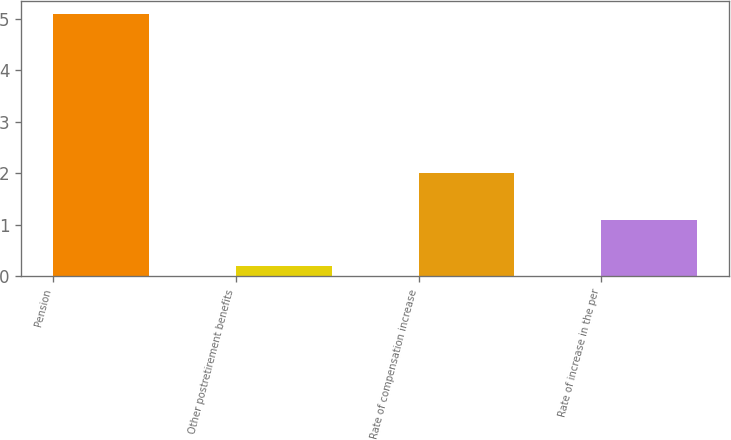Convert chart. <chart><loc_0><loc_0><loc_500><loc_500><bar_chart><fcel>Pension<fcel>Other postretirement benefits<fcel>Rate of compensation increase<fcel>Rate of increase in the per<nl><fcel>5.1<fcel>0.2<fcel>2<fcel>1.1<nl></chart> 